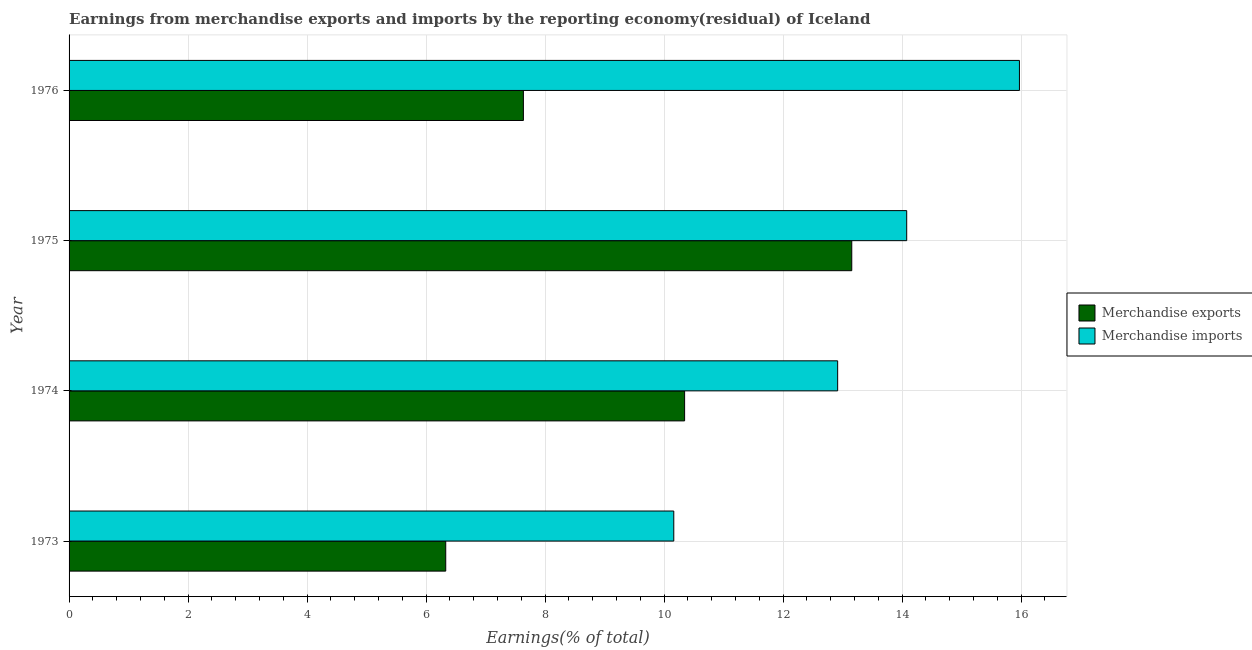How many different coloured bars are there?
Provide a succinct answer. 2. How many groups of bars are there?
Ensure brevity in your answer.  4. Are the number of bars per tick equal to the number of legend labels?
Provide a short and direct response. Yes. How many bars are there on the 4th tick from the top?
Offer a very short reply. 2. How many bars are there on the 1st tick from the bottom?
Give a very brief answer. 2. What is the label of the 1st group of bars from the top?
Give a very brief answer. 1976. What is the earnings from merchandise exports in 1973?
Offer a terse response. 6.33. Across all years, what is the maximum earnings from merchandise exports?
Keep it short and to the point. 13.15. Across all years, what is the minimum earnings from merchandise imports?
Offer a very short reply. 10.16. In which year was the earnings from merchandise exports maximum?
Keep it short and to the point. 1975. In which year was the earnings from merchandise imports minimum?
Provide a short and direct response. 1973. What is the total earnings from merchandise imports in the graph?
Ensure brevity in your answer.  53.12. What is the difference between the earnings from merchandise exports in 1973 and that in 1974?
Your answer should be compact. -4.01. What is the difference between the earnings from merchandise exports in 1975 and the earnings from merchandise imports in 1973?
Make the answer very short. 2.99. What is the average earnings from merchandise exports per year?
Offer a terse response. 9.37. In the year 1974, what is the difference between the earnings from merchandise exports and earnings from merchandise imports?
Your answer should be very brief. -2.57. In how many years, is the earnings from merchandise exports greater than 4.8 %?
Make the answer very short. 4. What is the ratio of the earnings from merchandise imports in 1975 to that in 1976?
Your answer should be very brief. 0.88. Is the earnings from merchandise exports in 1975 less than that in 1976?
Give a very brief answer. No. What is the difference between the highest and the second highest earnings from merchandise exports?
Your answer should be very brief. 2.81. What is the difference between the highest and the lowest earnings from merchandise exports?
Offer a very short reply. 6.82. Is the sum of the earnings from merchandise imports in 1973 and 1975 greater than the maximum earnings from merchandise exports across all years?
Your answer should be compact. Yes. What does the 2nd bar from the top in 1976 represents?
Your answer should be compact. Merchandise exports. What does the 2nd bar from the bottom in 1974 represents?
Offer a terse response. Merchandise imports. How many bars are there?
Make the answer very short. 8. Does the graph contain any zero values?
Make the answer very short. No. Does the graph contain grids?
Provide a succinct answer. Yes. How many legend labels are there?
Make the answer very short. 2. How are the legend labels stacked?
Provide a succinct answer. Vertical. What is the title of the graph?
Your answer should be compact. Earnings from merchandise exports and imports by the reporting economy(residual) of Iceland. Does "Official creditors" appear as one of the legend labels in the graph?
Your answer should be compact. No. What is the label or title of the X-axis?
Ensure brevity in your answer.  Earnings(% of total). What is the Earnings(% of total) of Merchandise exports in 1973?
Offer a terse response. 6.33. What is the Earnings(% of total) of Merchandise imports in 1973?
Keep it short and to the point. 10.16. What is the Earnings(% of total) in Merchandise exports in 1974?
Offer a terse response. 10.34. What is the Earnings(% of total) in Merchandise imports in 1974?
Keep it short and to the point. 12.92. What is the Earnings(% of total) in Merchandise exports in 1975?
Your answer should be very brief. 13.15. What is the Earnings(% of total) of Merchandise imports in 1975?
Offer a very short reply. 14.08. What is the Earnings(% of total) of Merchandise exports in 1976?
Your answer should be compact. 7.63. What is the Earnings(% of total) in Merchandise imports in 1976?
Your answer should be very brief. 15.97. Across all years, what is the maximum Earnings(% of total) in Merchandise exports?
Your answer should be compact. 13.15. Across all years, what is the maximum Earnings(% of total) in Merchandise imports?
Offer a very short reply. 15.97. Across all years, what is the minimum Earnings(% of total) of Merchandise exports?
Your response must be concise. 6.33. Across all years, what is the minimum Earnings(% of total) of Merchandise imports?
Give a very brief answer. 10.16. What is the total Earnings(% of total) of Merchandise exports in the graph?
Your response must be concise. 37.46. What is the total Earnings(% of total) of Merchandise imports in the graph?
Keep it short and to the point. 53.12. What is the difference between the Earnings(% of total) of Merchandise exports in 1973 and that in 1974?
Ensure brevity in your answer.  -4.01. What is the difference between the Earnings(% of total) in Merchandise imports in 1973 and that in 1974?
Provide a succinct answer. -2.75. What is the difference between the Earnings(% of total) of Merchandise exports in 1973 and that in 1975?
Ensure brevity in your answer.  -6.82. What is the difference between the Earnings(% of total) in Merchandise imports in 1973 and that in 1975?
Make the answer very short. -3.91. What is the difference between the Earnings(% of total) in Merchandise exports in 1973 and that in 1976?
Make the answer very short. -1.3. What is the difference between the Earnings(% of total) in Merchandise imports in 1973 and that in 1976?
Provide a short and direct response. -5.81. What is the difference between the Earnings(% of total) of Merchandise exports in 1974 and that in 1975?
Your answer should be compact. -2.81. What is the difference between the Earnings(% of total) of Merchandise imports in 1974 and that in 1975?
Offer a very short reply. -1.16. What is the difference between the Earnings(% of total) in Merchandise exports in 1974 and that in 1976?
Your answer should be compact. 2.71. What is the difference between the Earnings(% of total) in Merchandise imports in 1974 and that in 1976?
Offer a terse response. -3.05. What is the difference between the Earnings(% of total) of Merchandise exports in 1975 and that in 1976?
Provide a succinct answer. 5.52. What is the difference between the Earnings(% of total) in Merchandise imports in 1975 and that in 1976?
Offer a very short reply. -1.89. What is the difference between the Earnings(% of total) of Merchandise exports in 1973 and the Earnings(% of total) of Merchandise imports in 1974?
Offer a terse response. -6.59. What is the difference between the Earnings(% of total) in Merchandise exports in 1973 and the Earnings(% of total) in Merchandise imports in 1975?
Offer a terse response. -7.75. What is the difference between the Earnings(% of total) of Merchandise exports in 1973 and the Earnings(% of total) of Merchandise imports in 1976?
Provide a succinct answer. -9.64. What is the difference between the Earnings(% of total) of Merchandise exports in 1974 and the Earnings(% of total) of Merchandise imports in 1975?
Offer a very short reply. -3.73. What is the difference between the Earnings(% of total) in Merchandise exports in 1974 and the Earnings(% of total) in Merchandise imports in 1976?
Offer a terse response. -5.63. What is the difference between the Earnings(% of total) of Merchandise exports in 1975 and the Earnings(% of total) of Merchandise imports in 1976?
Your response must be concise. -2.82. What is the average Earnings(% of total) in Merchandise exports per year?
Ensure brevity in your answer.  9.37. What is the average Earnings(% of total) of Merchandise imports per year?
Keep it short and to the point. 13.28. In the year 1973, what is the difference between the Earnings(% of total) of Merchandise exports and Earnings(% of total) of Merchandise imports?
Offer a terse response. -3.83. In the year 1974, what is the difference between the Earnings(% of total) of Merchandise exports and Earnings(% of total) of Merchandise imports?
Offer a very short reply. -2.57. In the year 1975, what is the difference between the Earnings(% of total) in Merchandise exports and Earnings(% of total) in Merchandise imports?
Give a very brief answer. -0.92. In the year 1976, what is the difference between the Earnings(% of total) of Merchandise exports and Earnings(% of total) of Merchandise imports?
Offer a very short reply. -8.34. What is the ratio of the Earnings(% of total) of Merchandise exports in 1973 to that in 1974?
Make the answer very short. 0.61. What is the ratio of the Earnings(% of total) of Merchandise imports in 1973 to that in 1974?
Offer a terse response. 0.79. What is the ratio of the Earnings(% of total) of Merchandise exports in 1973 to that in 1975?
Provide a short and direct response. 0.48. What is the ratio of the Earnings(% of total) of Merchandise imports in 1973 to that in 1975?
Your response must be concise. 0.72. What is the ratio of the Earnings(% of total) of Merchandise exports in 1973 to that in 1976?
Ensure brevity in your answer.  0.83. What is the ratio of the Earnings(% of total) of Merchandise imports in 1973 to that in 1976?
Your response must be concise. 0.64. What is the ratio of the Earnings(% of total) of Merchandise exports in 1974 to that in 1975?
Your response must be concise. 0.79. What is the ratio of the Earnings(% of total) of Merchandise imports in 1974 to that in 1975?
Make the answer very short. 0.92. What is the ratio of the Earnings(% of total) of Merchandise exports in 1974 to that in 1976?
Offer a very short reply. 1.35. What is the ratio of the Earnings(% of total) in Merchandise imports in 1974 to that in 1976?
Keep it short and to the point. 0.81. What is the ratio of the Earnings(% of total) in Merchandise exports in 1975 to that in 1976?
Make the answer very short. 1.72. What is the ratio of the Earnings(% of total) in Merchandise imports in 1975 to that in 1976?
Provide a short and direct response. 0.88. What is the difference between the highest and the second highest Earnings(% of total) of Merchandise exports?
Offer a very short reply. 2.81. What is the difference between the highest and the second highest Earnings(% of total) in Merchandise imports?
Your answer should be very brief. 1.89. What is the difference between the highest and the lowest Earnings(% of total) of Merchandise exports?
Ensure brevity in your answer.  6.82. What is the difference between the highest and the lowest Earnings(% of total) in Merchandise imports?
Give a very brief answer. 5.81. 